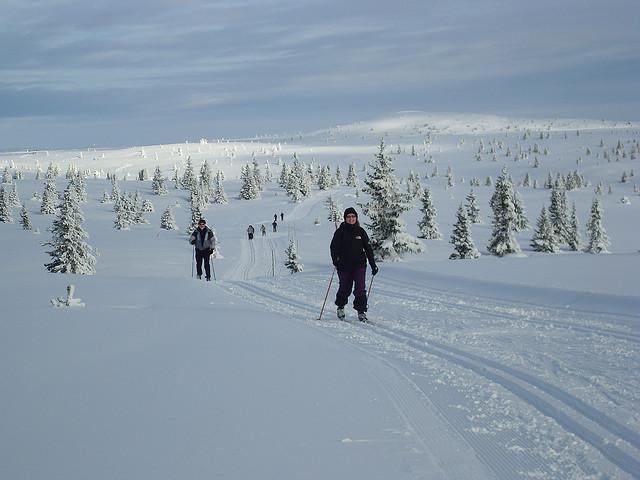What must the weather be like in this area?
Select the correct answer and articulate reasoning with the following format: 'Answer: answer
Rationale: rationale.'
Options: Tropical, warm, mild, cold. Answer: cold.
Rationale: The area is snowy so it must be cold. 